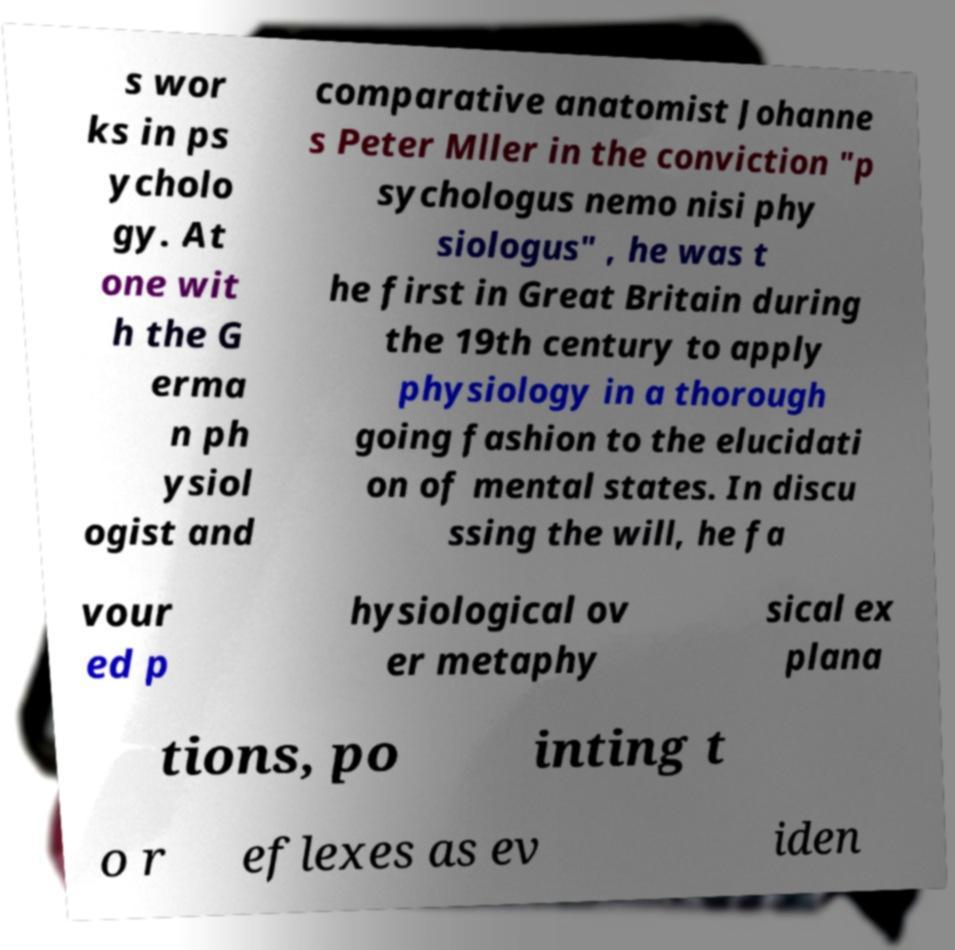Can you read and provide the text displayed in the image?This photo seems to have some interesting text. Can you extract and type it out for me? s wor ks in ps ycholo gy. At one wit h the G erma n ph ysiol ogist and comparative anatomist Johanne s Peter Mller in the conviction "p sychologus nemo nisi phy siologus" , he was t he first in Great Britain during the 19th century to apply physiology in a thorough going fashion to the elucidati on of mental states. In discu ssing the will, he fa vour ed p hysiological ov er metaphy sical ex plana tions, po inting t o r eflexes as ev iden 